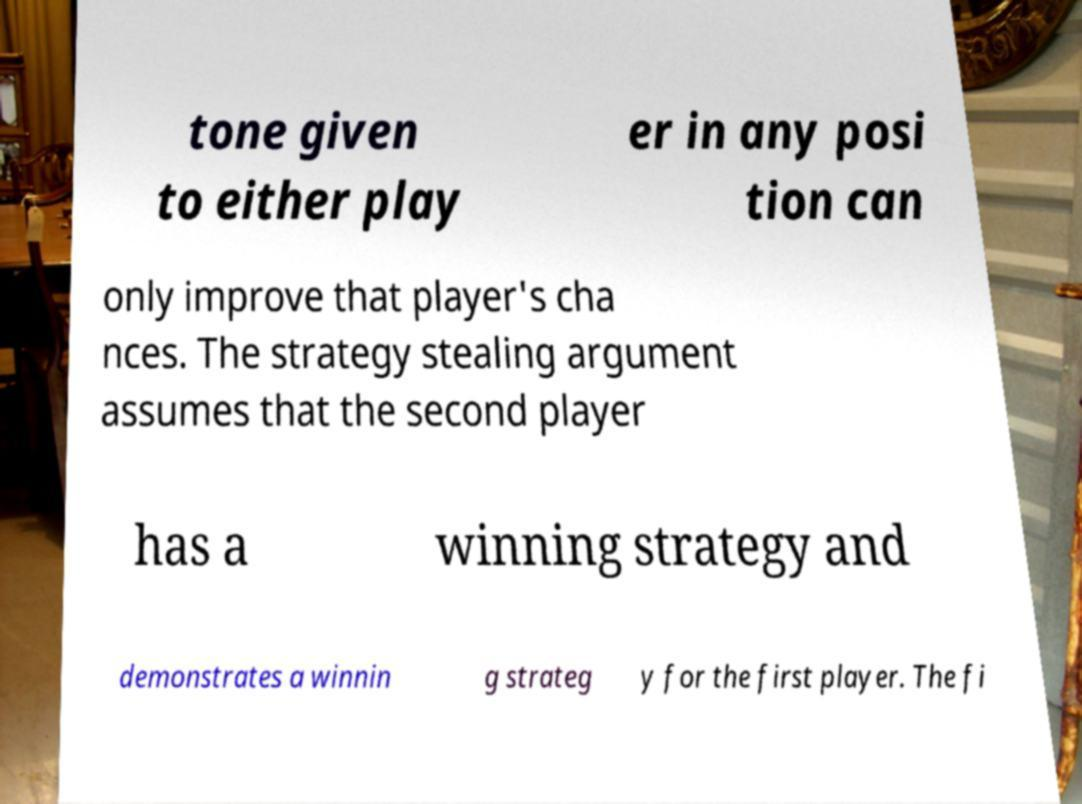For documentation purposes, I need the text within this image transcribed. Could you provide that? tone given to either play er in any posi tion can only improve that player's cha nces. The strategy stealing argument assumes that the second player has a winning strategy and demonstrates a winnin g strateg y for the first player. The fi 